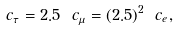Convert formula to latex. <formula><loc_0><loc_0><loc_500><loc_500>c _ { \tau } = 2 . 5 \ c _ { \mu } = ( 2 . 5 ) ^ { 2 } \ c _ { e } ,</formula> 